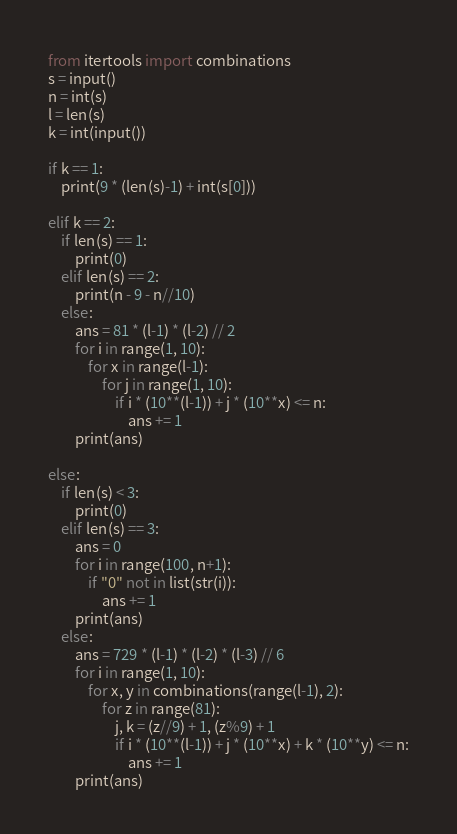<code> <loc_0><loc_0><loc_500><loc_500><_Python_>from itertools import combinations
s = input()
n = int(s)
l = len(s)
k = int(input())

if k == 1:
	print(9 * (len(s)-1) + int(s[0]))

elif k == 2:
	if len(s) == 1:
		print(0)
	elif len(s) == 2:
		print(n - 9 - n//10)
	else:
		ans = 81 * (l-1) * (l-2) // 2
		for i in range(1, 10):
			for x in range(l-1):
				for j in range(1, 10):
					if i * (10**(l-1)) + j * (10**x) <= n:
						ans += 1
		print(ans)

else:
	if len(s) < 3:
		print(0)
	elif len(s) == 3:
		ans = 0
		for i in range(100, n+1):
			if "0" not in list(str(i)):
				ans += 1
		print(ans)
	else:
		ans = 729 * (l-1) * (l-2) * (l-3) // 6
		for i in range(1, 10):
			for x, y in combinations(range(l-1), 2):
				for z in range(81):
					j, k = (z//9) + 1, (z%9) + 1
					if i * (10**(l-1)) + j * (10**x) + k * (10**y) <= n:
						ans += 1
		print(ans)</code> 